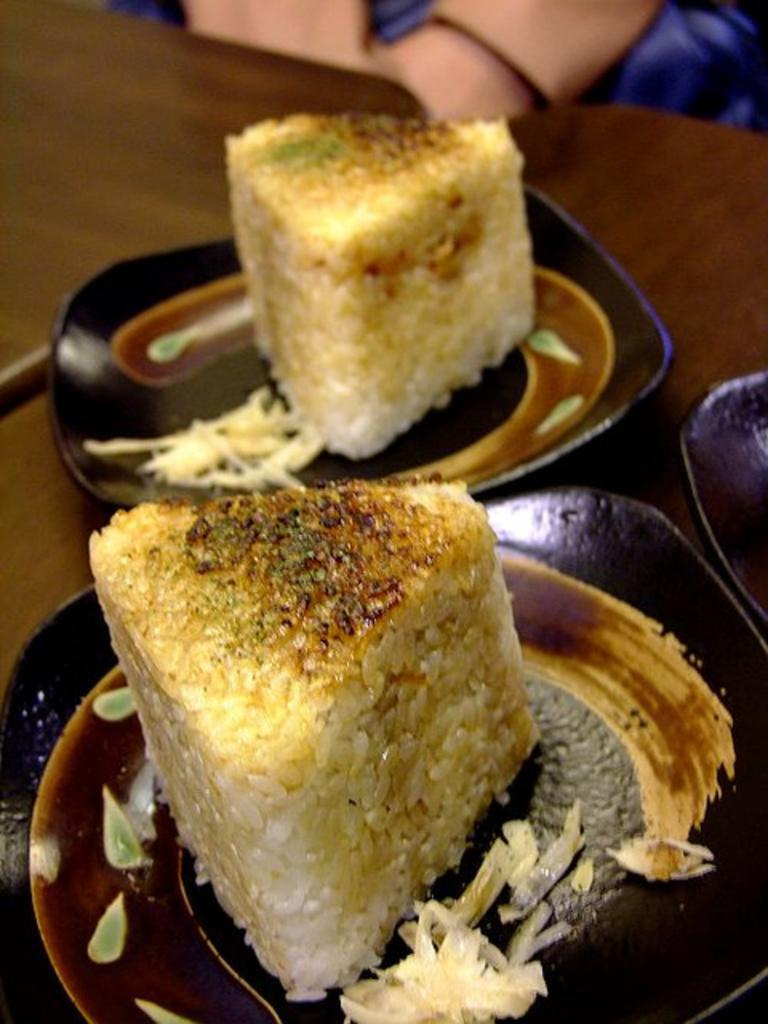How many plates are visible in the image? There are two brown color plates in the image. What is on the plates? The plates contain food. Can you describe the color of the food? The food is white and brown in color. Where are the plates placed? The plates are placed on a brown color table. What type of verse can be seen written on the curtain in the image? There is no curtain present in the image, so it is not possible to determine if there is any verse written on it. 